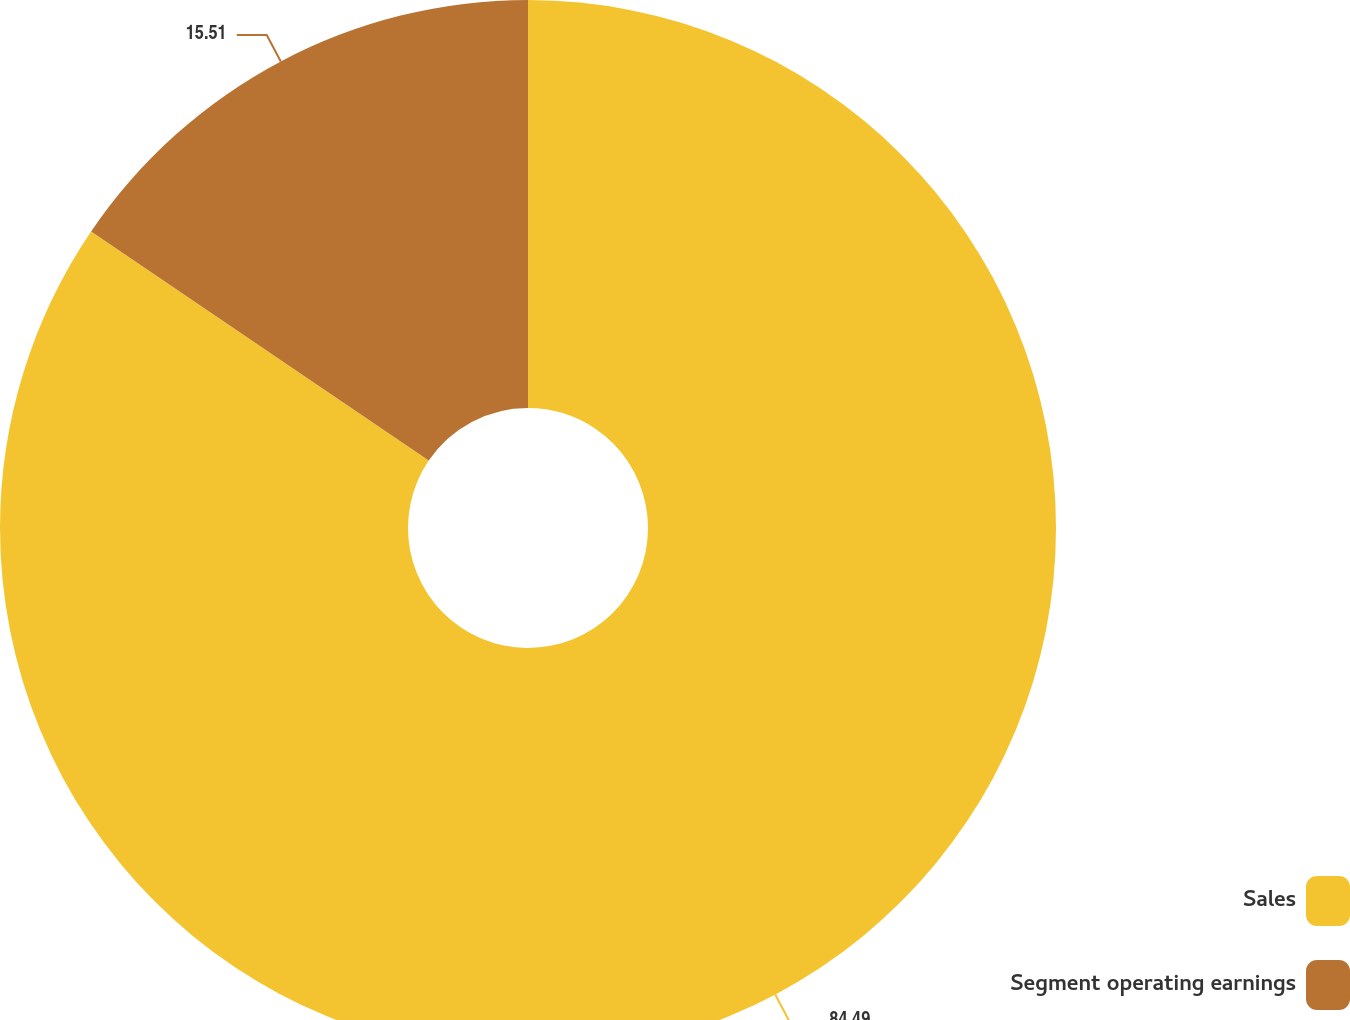<chart> <loc_0><loc_0><loc_500><loc_500><pie_chart><fcel>Sales<fcel>Segment operating earnings<nl><fcel>84.49%<fcel>15.51%<nl></chart> 